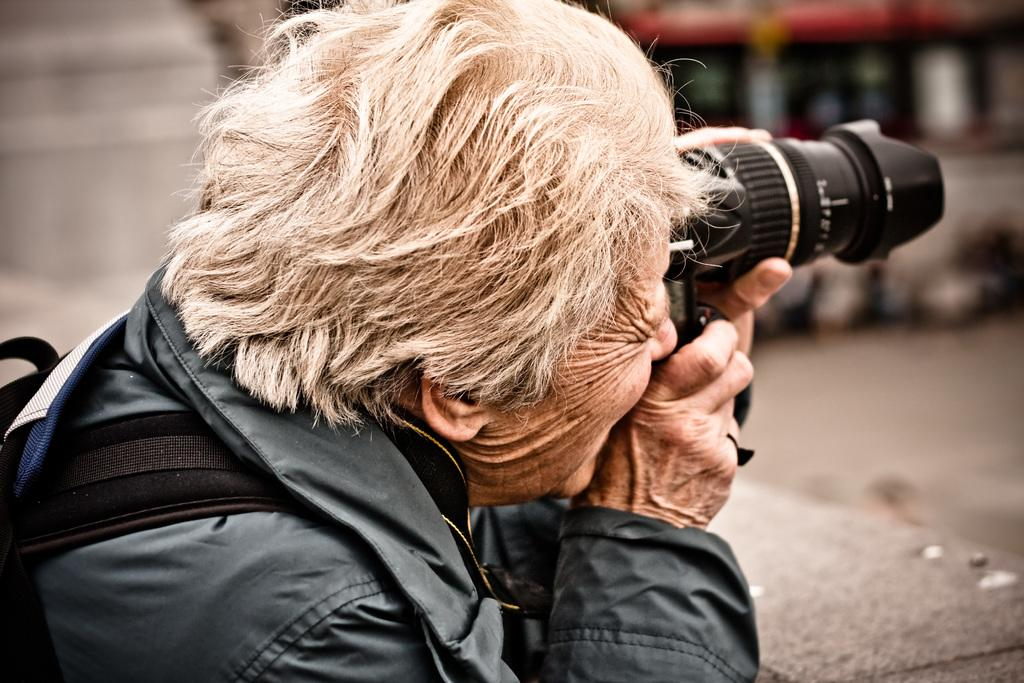What can be seen in the image? There is a person in the image. Can you describe the person's appearance? The person has white hair and wrinkles on their face. What is the person wearing? The person is wearing a jacket and a backpack on their shoulders. What is the person holding? The person is holding a camera. How does the person increase their memory capacity in the image? There is no indication in the image that the person is trying to increase their memory capacity. 